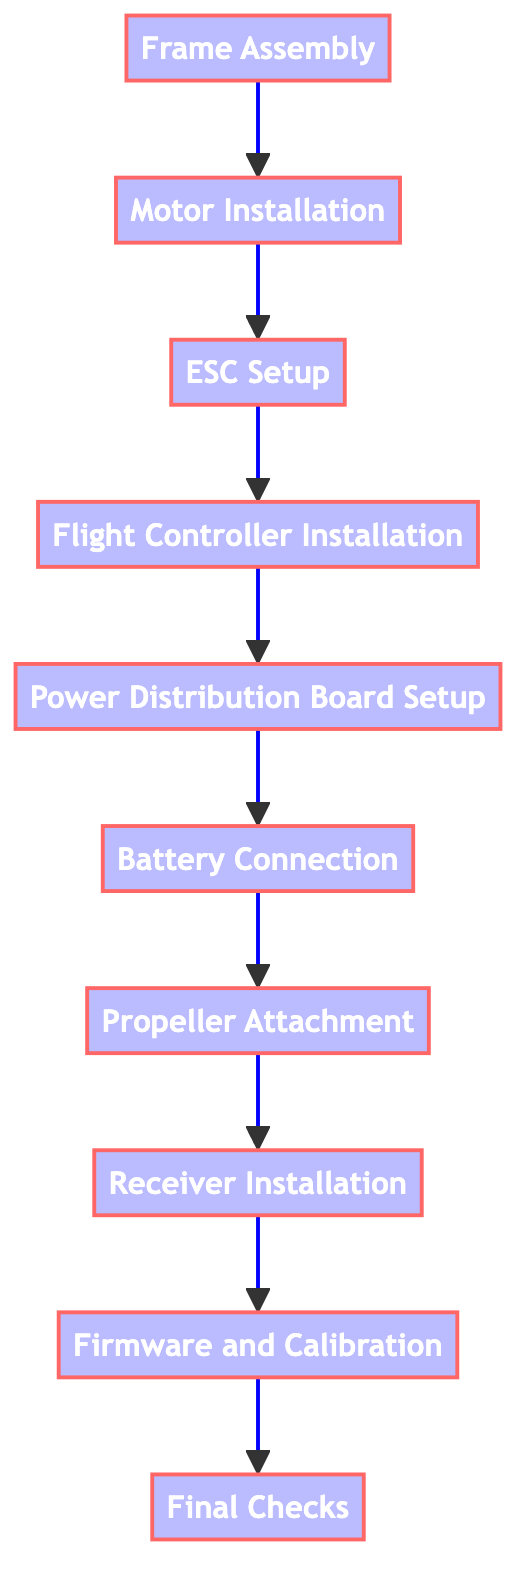What is the first step in the assembly process? The first step listed in the diagram is "Frame Assembly." This is connected at the topmost point of the flowchart, indicating it is the initial action.
Answer: Frame Assembly How many total steps are involved in the assembly process? The diagram shows a total of 10 distinct steps from "Frame Assembly" to "Final Checks," as represented by the 10 nodes in the flowchart.
Answer: 10 Which step follows "Motor Installation"? The diagram establishes a direct sequence from "Motor Installation" to "ESC Setup," denoted by the arrow linking the two processes.
Answer: ESC Setup What are the last two steps in the assembly process? The final two steps that are portrayed in the flowchart are "Firmware and Calibration" and "Final Checks," which are the last two nodes in the sequence.
Answer: Firmware and Calibration, Final Checks List the items needed for “Power Distribution Board Setup." The description for "Power Distribution Board Setup" states that the required items are "Power Distribution Board, Soldering iron, Wires." This is extracted from the element’s description section in the flowchart.
Answer: Power Distribution Board, Soldering iron, Wires What is required to connect the battery? The step under "Battery Connection" indicates that an "XT60 Connector" is necessary to connect the battery to the Power Distribution Board (PDB).
Answer: XT60 Connector Which step involves the use of double-sided tape? The "Receiver Installation" step specifies using double-sided tape to mount the radio receiver, indicated in the description provided for that node.
Answer: Receiver Installation What comes after installing the flight controller? According to the flowchart, the step that follows "Flight Controller Installation" is "Power Distribution Board Setup," represented by the connecting arrow.
Answer: Power Distribution Board Setup What is the main purpose of the "Final Checks" step? The "Final Checks" step is primarily intended to verify all connections are secure and to perform a pre-flight check, ensuring the functionality of all components is correct before flight.
Answer: Verify connections, pre-flight check 